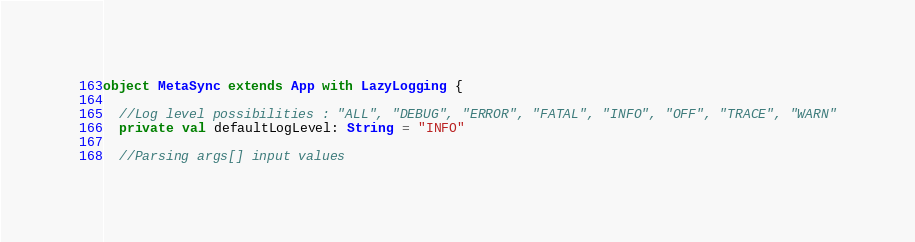<code> <loc_0><loc_0><loc_500><loc_500><_Scala_>object MetaSync extends App with LazyLogging {

  //Log level possibilities : "ALL", "DEBUG", "ERROR", "FATAL", "INFO", "OFF", "TRACE", "WARN"
  private val defaultLogLevel: String = "INFO"

  //Parsing args[] input values</code> 